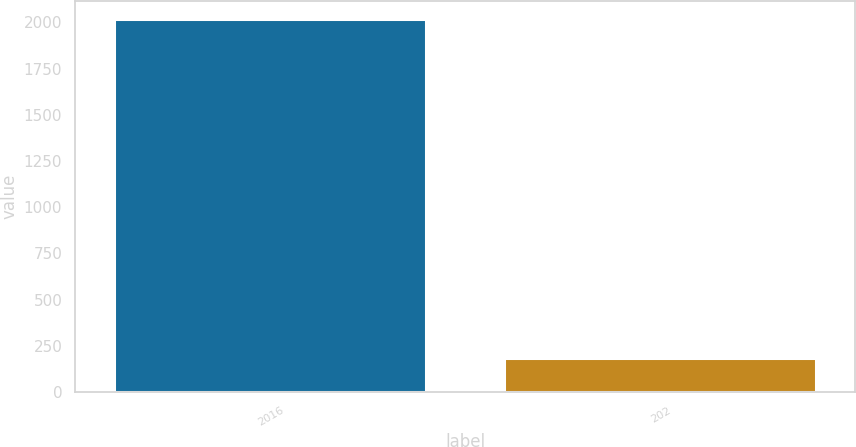Convert chart. <chart><loc_0><loc_0><loc_500><loc_500><bar_chart><fcel>2016<fcel>202<nl><fcel>2017<fcel>183<nl></chart> 